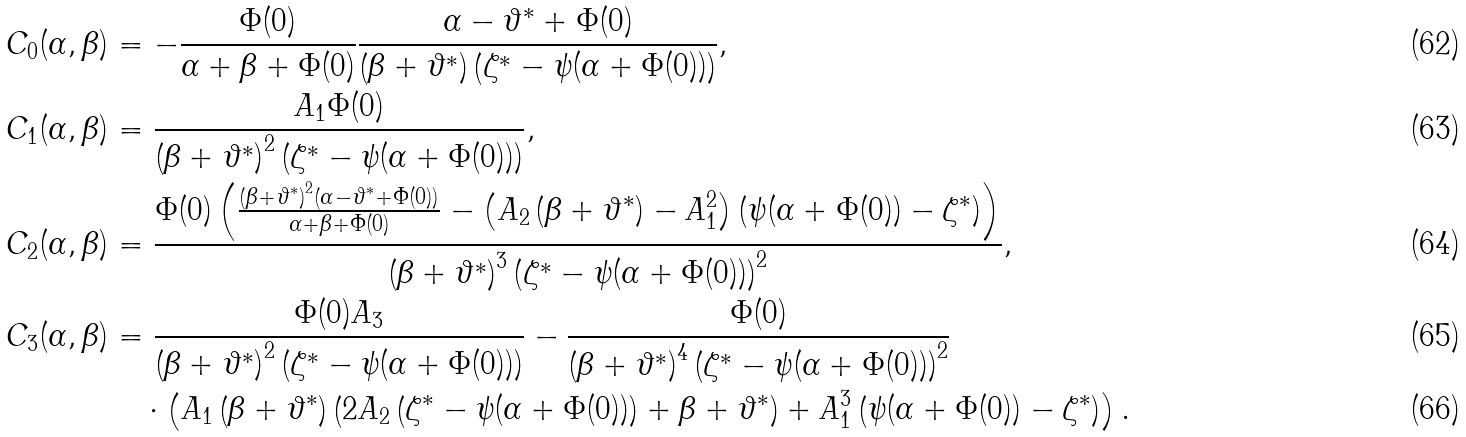Convert formula to latex. <formula><loc_0><loc_0><loc_500><loc_500>C _ { 0 } ( \alpha , \beta ) & = - \frac { \Phi ( 0 ) } { \alpha + \beta + \Phi ( 0 ) } \frac { \alpha - \vartheta ^ { * } + \Phi ( 0 ) } { \left ( \beta + \vartheta ^ { * } \right ) \left ( \zeta ^ { * } - \psi ( \alpha + \Phi ( 0 ) ) \right ) } , \\ C _ { 1 } ( \alpha , \beta ) & = \frac { A _ { 1 } \Phi ( 0 ) } { \left ( \beta + \vartheta ^ { * } \right ) ^ { 2 } \left ( \zeta ^ { * } - \psi ( \alpha + \Phi ( 0 ) ) \right ) } , \\ C _ { 2 } ( \alpha , \beta ) & = \frac { \Phi ( 0 ) \left ( \frac { \left ( \beta + \vartheta ^ { * } \right ) ^ { 2 } \left ( \alpha - \vartheta ^ { * } + \Phi ( 0 ) \right ) } { \alpha + \beta + \Phi ( 0 ) } - \left ( A _ { 2 } \left ( \beta + \vartheta ^ { * } \right ) - A _ { 1 } ^ { 2 } \right ) \left ( \psi ( \alpha + \Phi ( 0 ) ) - \zeta ^ { * } \right ) \right ) } { \left ( \beta + \vartheta ^ { * } \right ) ^ { 3 } \left ( \zeta ^ { * } - \psi ( \alpha + \Phi ( 0 ) ) \right ) ^ { 2 } } , \\ C _ { 3 } ( \alpha , \beta ) & = \frac { \Phi ( 0 ) A _ { 3 } } { \left ( \beta + \vartheta ^ { * } \right ) ^ { 2 } \left ( \zeta ^ { * } - \psi ( \alpha + \Phi ( 0 ) ) \right ) } - \frac { \Phi ( 0 ) } { \left ( \beta + \vartheta ^ { * } \right ) ^ { 4 } \left ( \zeta ^ { * } - \psi ( \alpha + \Phi ( 0 ) ) \right ) ^ { 2 } } \\ & \quad \cdot \left ( A _ { 1 } \left ( \beta + \vartheta ^ { * } \right ) \left ( 2 A _ { 2 } \left ( \zeta ^ { * } - \psi ( \alpha + \Phi ( 0 ) ) \right ) + \beta + \vartheta ^ { * } \right ) + A _ { 1 } ^ { 3 } \left ( \psi ( \alpha + \Phi ( 0 ) ) - \zeta ^ { * } \right ) \right ) .</formula> 